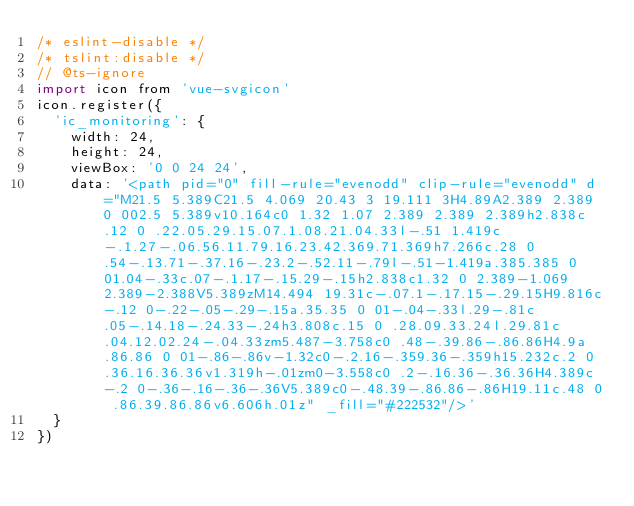<code> <loc_0><loc_0><loc_500><loc_500><_JavaScript_>/* eslint-disable */
/* tslint:disable */
// @ts-ignore
import icon from 'vue-svgicon'
icon.register({
  'ic_monitoring': {
    width: 24,
    height: 24,
    viewBox: '0 0 24 24',
    data: '<path pid="0" fill-rule="evenodd" clip-rule="evenodd" d="M21.5 5.389C21.5 4.069 20.43 3 19.111 3H4.89A2.389 2.389 0 002.5 5.389v10.164c0 1.32 1.07 2.389 2.389 2.389h2.838c.12 0 .22.05.29.15.07.1.08.21.04.33l-.51 1.419c-.1.27-.06.56.11.79.16.23.42.369.71.369h7.266c.28 0 .54-.13.71-.37.16-.23.2-.52.11-.79l-.51-1.419a.385.385 0 01.04-.33c.07-.1.17-.15.29-.15h2.838c1.32 0 2.389-1.069 2.389-2.388V5.389zM14.494 19.31c-.07.1-.17.15-.29.15H9.816c-.12 0-.22-.05-.29-.15a.35.35 0 01-.04-.33l.29-.81c.05-.14.18-.24.33-.24h3.808c.15 0 .28.09.33.24l.29.81c.04.12.02.24-.04.33zm5.487-3.758c0 .48-.39.86-.86.86H4.9a.86.86 0 01-.86-.86v-1.32c0-.2.16-.359.36-.359h15.232c.2 0 .36.16.36.36v1.319h-.01zm0-3.558c0 .2-.16.36-.36.36H4.389c-.2 0-.36-.16-.36-.36V5.389c0-.48.39-.86.86-.86H19.11c.48 0 .86.39.86.86v6.606h.01z" _fill="#222532"/>'
  }
})
</code> 